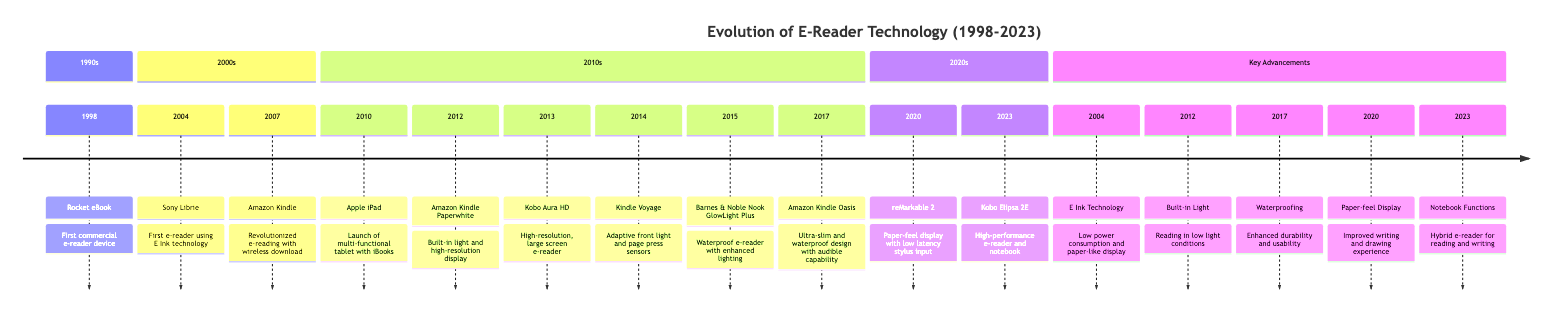What was the first commercial e-reader device? The timeline indicates that the first commercial e-reader device launched in 1998 was the "Rocket eBook."
Answer: Rocket eBook Which e-reader introduced E Ink technology? The timeline specifies that the "Sony Librie," released in 2004, was the first e-reader to use E Ink technology.
Answer: Sony Librie How many key advancements are listed in the diagram? A review of the diagram shows that there are five key advancements outlined, each corresponding to a specific year and innovation.
Answer: 5 What significant feature was introduced in the 2012 Amazon Kindle Paperwhite? The diagram reveals that the 2012 Amazon Kindle Paperwhite featured a "built-in light," which allowed reading in low light conditions.
Answer: built-in light Which e-reader launched in 2023? According to the timeline, the e-reader that launched in 2023 is the "Kobo Elipsa 2E."
Answer: Kobo Elipsa 2E What advancement regarding waterproofing was made in 2017? The 2017 entry indicates that the "Amazon Kindle Oasis" introduced waterproofing, enhancing durability and usability.
Answer: Waterproofing What year did the Apple iPad launch? The diagram clearly states that the Apple iPad was launched in 2010.
Answer: 2010 Which e-reader introduced a paper-feel display? A look at the 2020 section of the timeline highlights that the "reMarkable 2" introduced the paper-feel display.
Answer: reMarkable 2 What does the hybrid e-reader in 2023 allow users to do? By analyzing the 2023 entry for Kobo Elipsa 2E, it indicates that it has "notebook functions," which allows for both reading and writing.
Answer: Notebook Functions 